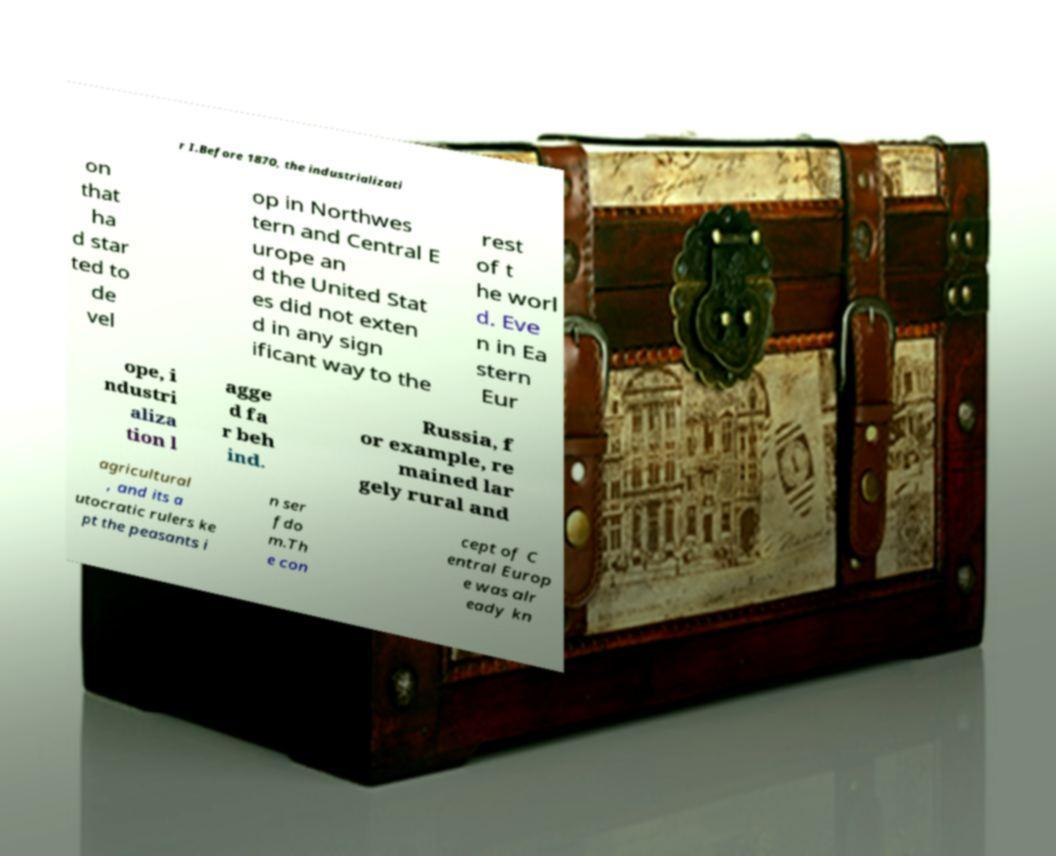Can you accurately transcribe the text from the provided image for me? r I.Before 1870, the industrializati on that ha d star ted to de vel op in Northwes tern and Central E urope an d the United Stat es did not exten d in any sign ificant way to the rest of t he worl d. Eve n in Ea stern Eur ope, i ndustri aliza tion l agge d fa r beh ind. Russia, f or example, re mained lar gely rural and agricultural , and its a utocratic rulers ke pt the peasants i n ser fdo m.Th e con cept of C entral Europ e was alr eady kn 